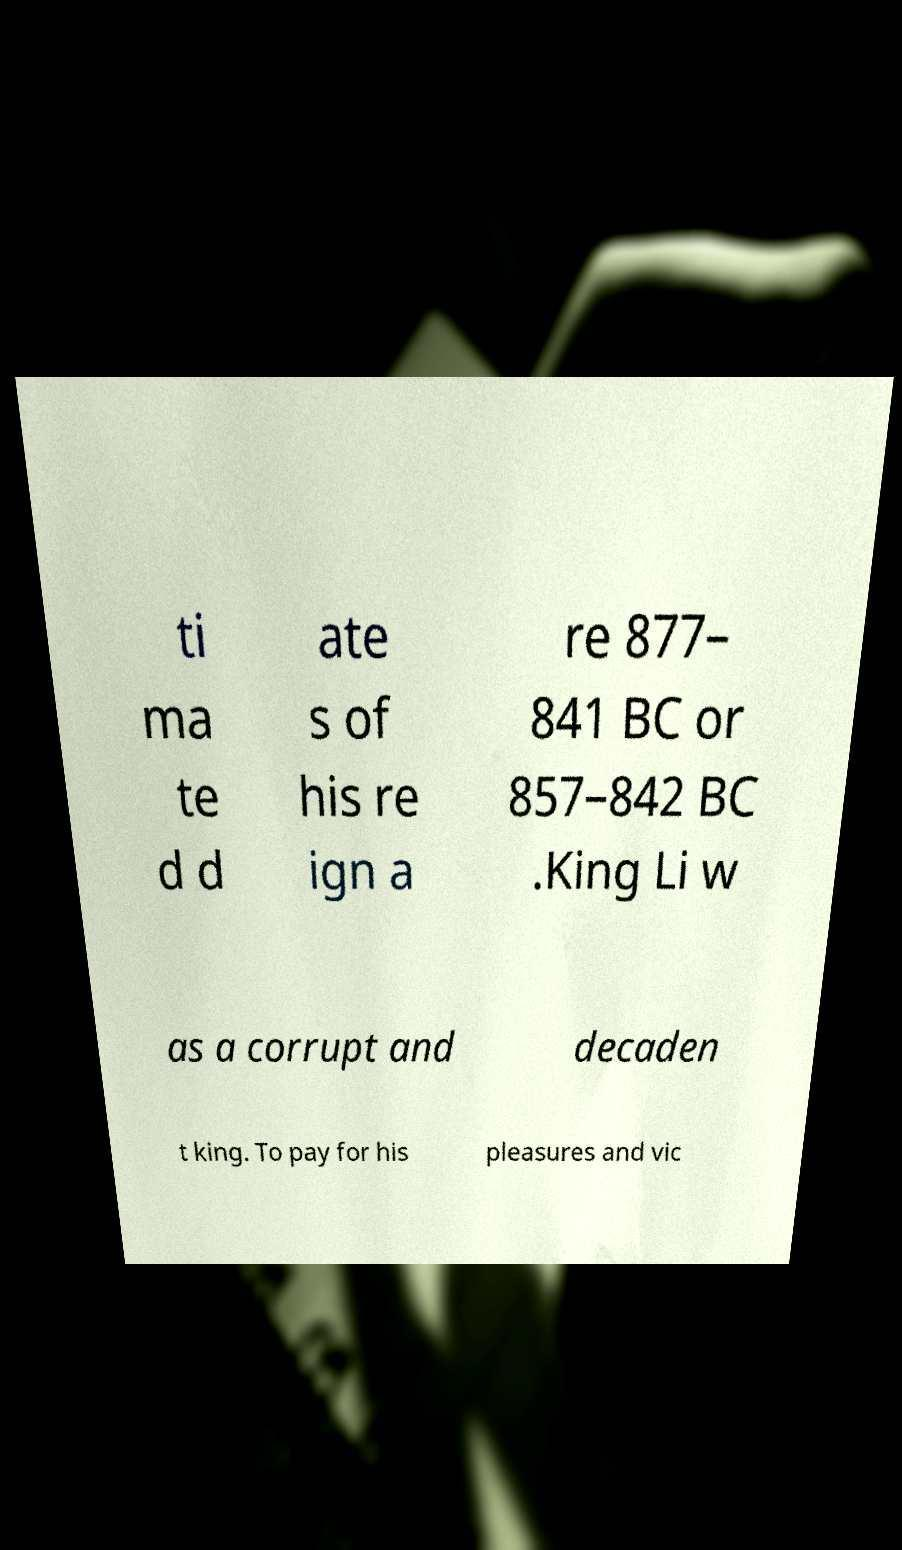What messages or text are displayed in this image? I need them in a readable, typed format. ti ma te d d ate s of his re ign a re 877– 841 BC or 857–842 BC .King Li w as a corrupt and decaden t king. To pay for his pleasures and vic 